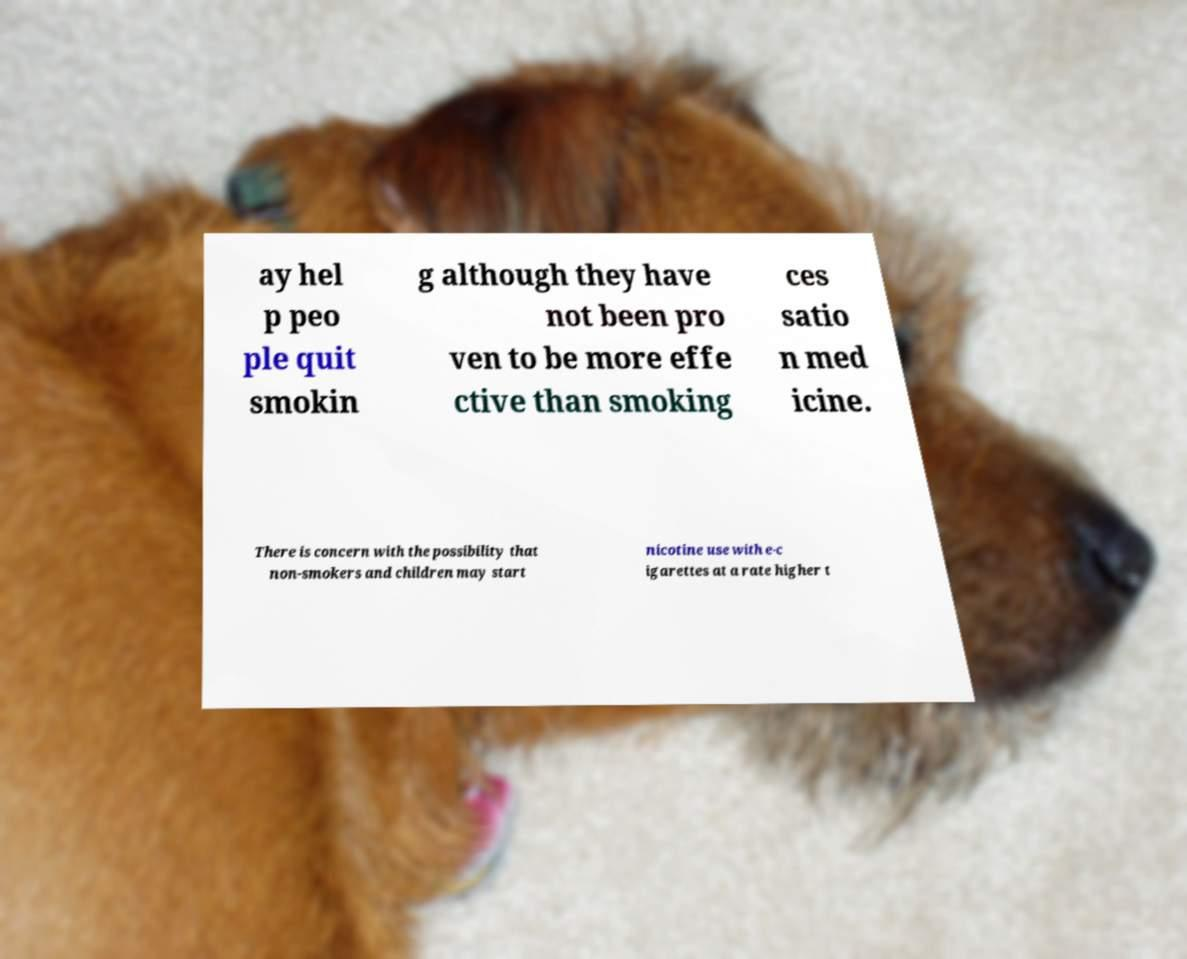For documentation purposes, I need the text within this image transcribed. Could you provide that? ay hel p peo ple quit smokin g although they have not been pro ven to be more effe ctive than smoking ces satio n med icine. There is concern with the possibility that non-smokers and children may start nicotine use with e-c igarettes at a rate higher t 